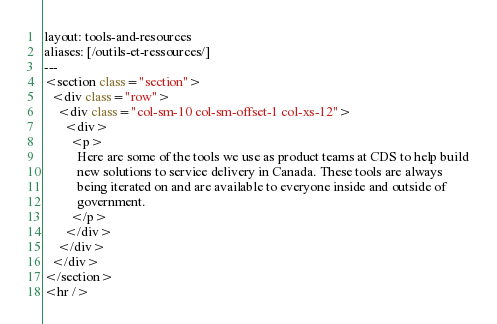Convert code to text. <code><loc_0><loc_0><loc_500><loc_500><_HTML_>layout: tools-and-resources
aliases: [/outils-et-ressources/]
---
<section class="section">
  <div class="row">
    <div class="col-sm-10 col-sm-offset-1 col-xs-12">
      <div>
        <p>
          Here are some of the tools we use as product teams at CDS to help build
          new solutions to service delivery in Canada. These tools are always
          being iterated on and are available to everyone inside and outside of
          government.
        </p>
      </div>
    </div>
  </div>
</section>
<hr />
</code> 